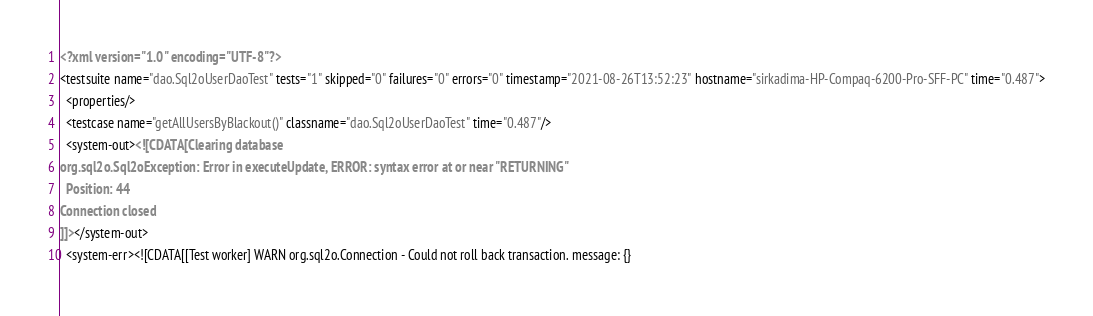<code> <loc_0><loc_0><loc_500><loc_500><_XML_><?xml version="1.0" encoding="UTF-8"?>
<testsuite name="dao.Sql2oUserDaoTest" tests="1" skipped="0" failures="0" errors="0" timestamp="2021-08-26T13:52:23" hostname="sirkadima-HP-Compaq-6200-Pro-SFF-PC" time="0.487">
  <properties/>
  <testcase name="getAllUsersByBlackout()" classname="dao.Sql2oUserDaoTest" time="0.487"/>
  <system-out><![CDATA[Clearing database
org.sql2o.Sql2oException: Error in executeUpdate, ERROR: syntax error at or near "RETURNING"
  Position: 44
Connection closed
]]></system-out>
  <system-err><![CDATA[[Test worker] WARN org.sql2o.Connection - Could not roll back transaction. message: {}</code> 